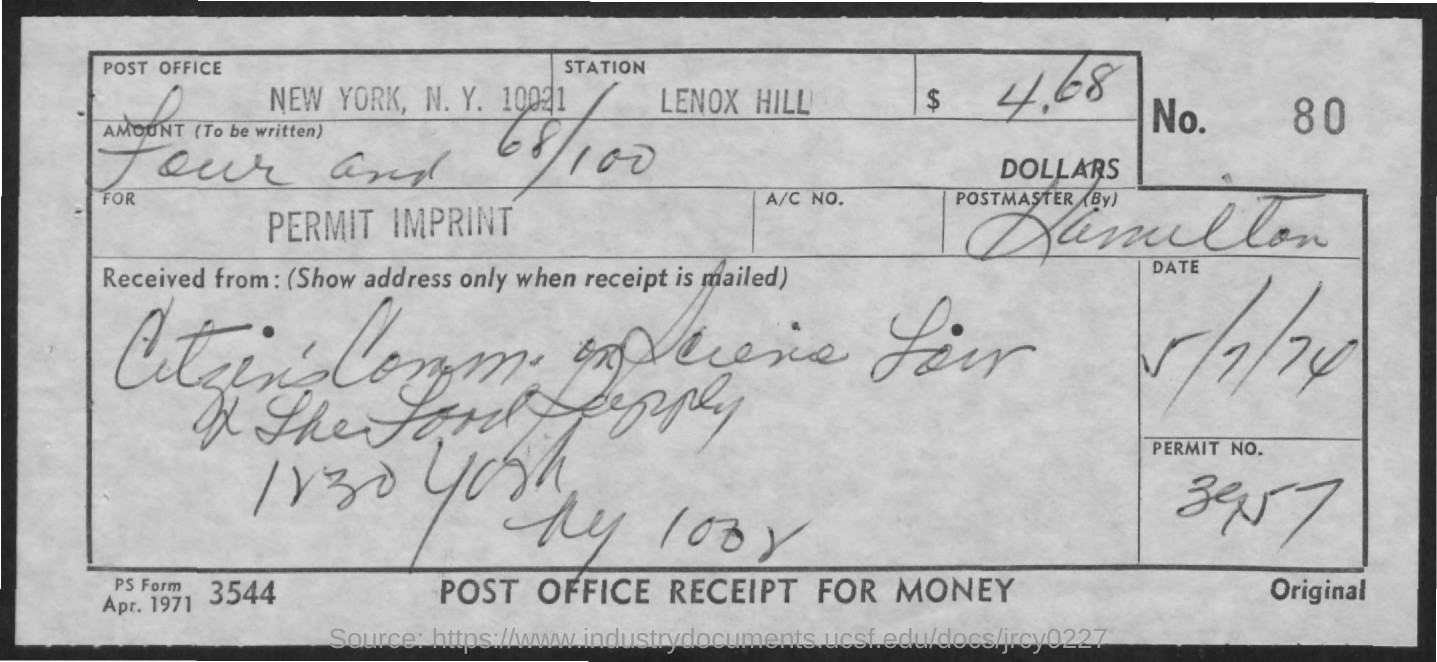Point out several critical features in this image. The document contains a date of May 7, 1974. It is known that the name of the Station is Lenox Hill. The name of the Post Office located in New York, New York is 10021. The form number is 3544. The permit number is 3957. 